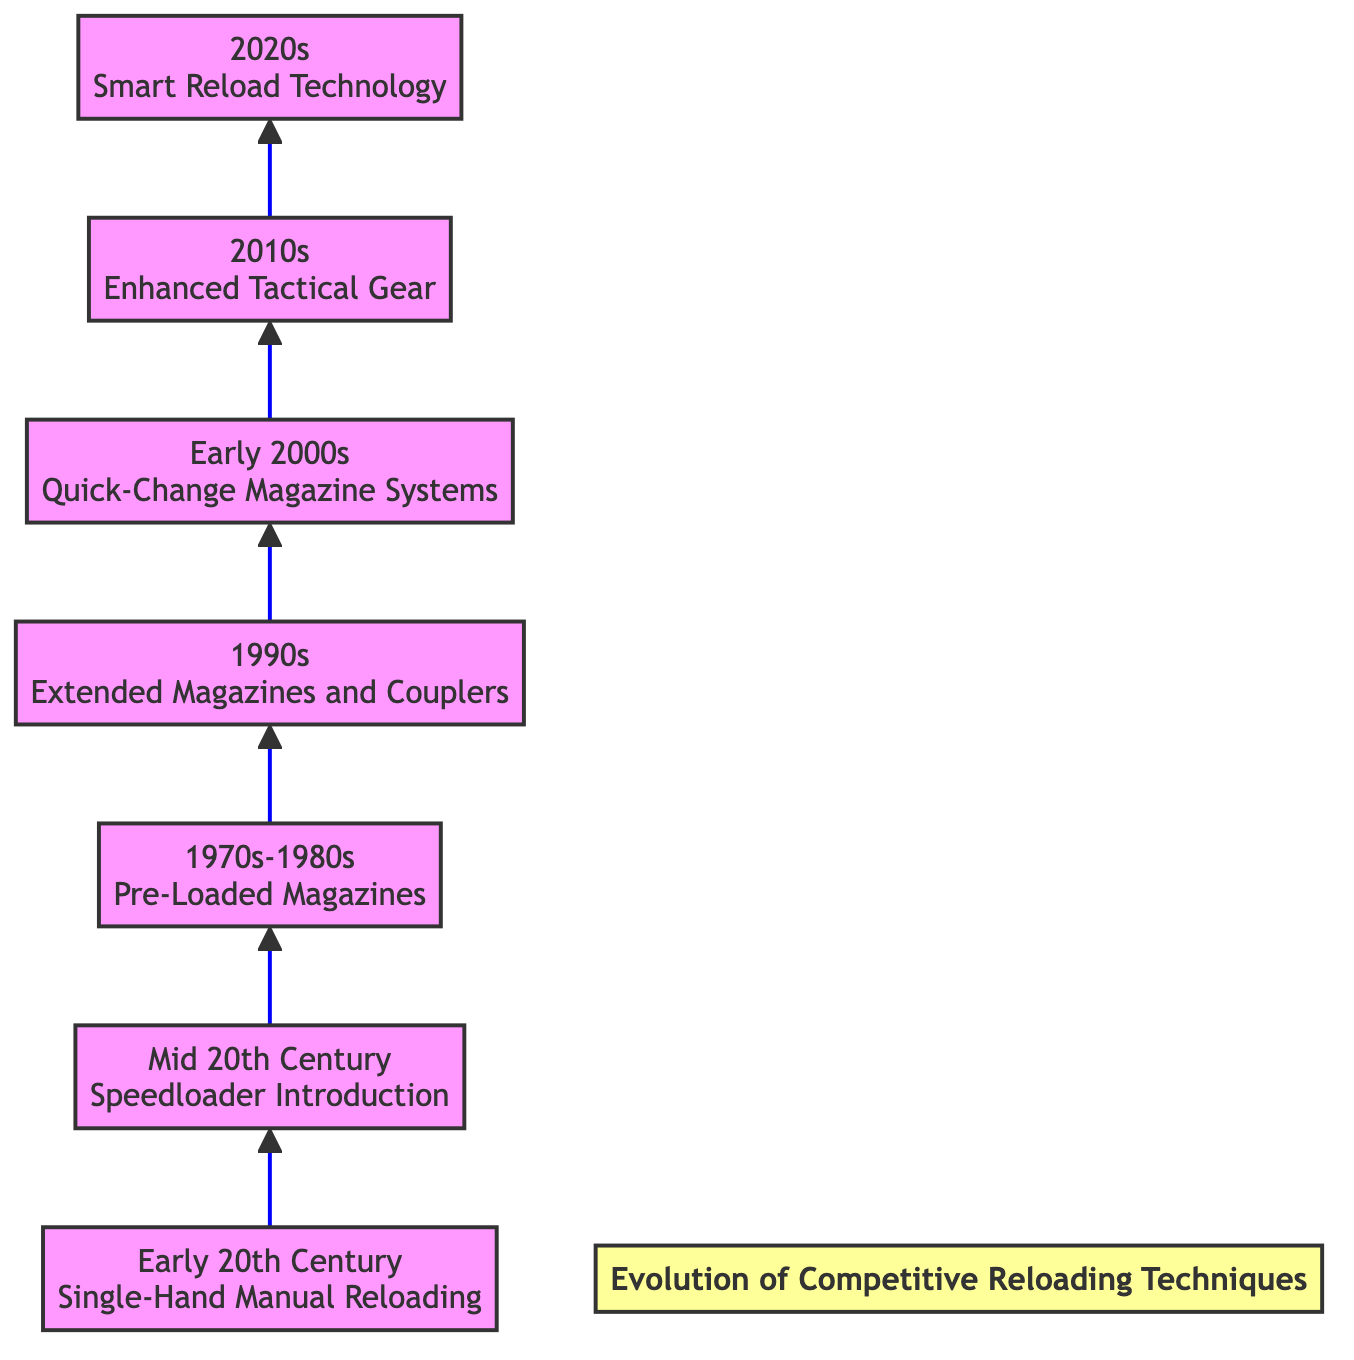What technique was used in the Early 20th Century? The diagram indicates that the technique used in the Early 20th Century was "Single-Hand Manual Reloading," as shown in the first node at the bottom of the flow chart.
Answer: Single-Hand Manual Reloading How many techniques are listed in the diagram? To find the number of techniques, we count the individual nodes labeled with techniques in the flow chart. There are a total of seven techniques listed.
Answer: 7 What period is associated with the introduction of Smart Reload Technology? The final node at the top of the diagram indicates that the "Smart Reload Technology" pertains to the period of the 2020s.
Answer: 2020s Which technique introduced in the Mid 20th Century improved reloading efficiency? According to the second node in the diagram, the "Speedloader Introduction" improved reloading efficiency in the Mid 20th Century.
Answer: Speedloader Introduction What period saw the use of Extended Magazines and Magazine Couplers? The diagram shows that the use of "Extended Magazines and Magazine Couplers" occurred during the 1990s, as indicated in the corresponding node.
Answer: 1990s Which technique allows for faster reloading with better magazine swaps? The node for "Pre-Loaded Magazines" in the diagram specifies that this technique allows for quicker reloading by swapping magazines, indicating its key function in improving speed.
Answer: Pre-Loaded Magazines Describe the evolution trend indicated by the flow chart. The diagram displays a progression in competitive reloading techniques from manual methods to electronic innovations. It clearly shows advancements in technology and gear leading to more efficient techniques over time, emphasizing an upward trend in capability and speed.
Answer: Technological advancement What was a notable feature of the reload techniques in the Early 2000s? The diagram describes "Quick-Change Magazine Systems" as a notable feature from the Early 2000s, highlighting innovations in magazine release mechanisms.
Answer: Quick-Change Magazine Systems 